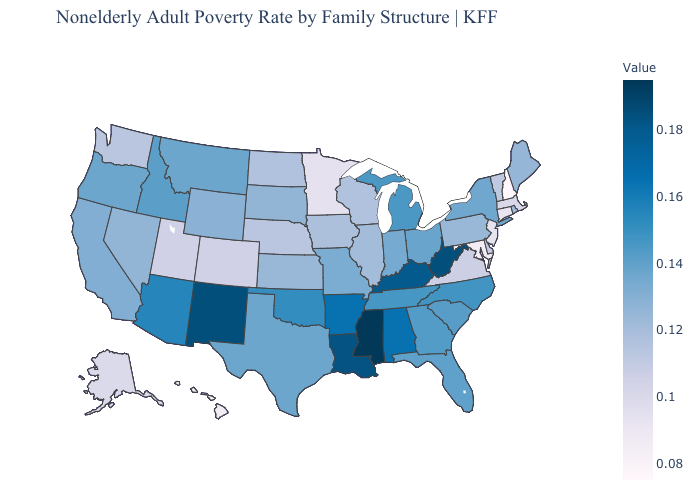Which states hav the highest value in the Northeast?
Be succinct. New York. Which states have the highest value in the USA?
Short answer required. Mississippi. Does the map have missing data?
Keep it brief. No. Does Maine have a higher value than Utah?
Answer briefly. Yes. Which states hav the highest value in the South?
Give a very brief answer. Mississippi. Does South Dakota have a higher value than New Mexico?
Quick response, please. No. Does Colorado have a lower value than Idaho?
Short answer required. Yes. 